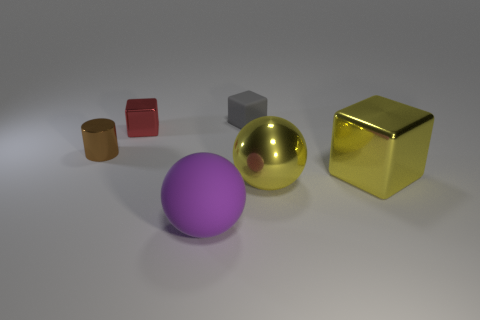What can you infer about the texture of the purple sphere? The purple sphere appears to have a matte texture, as it does not reflect light as intensely as the metallic objects. Its surface seems smooth, with an even distribution of light, indicating a lack of roughness. 